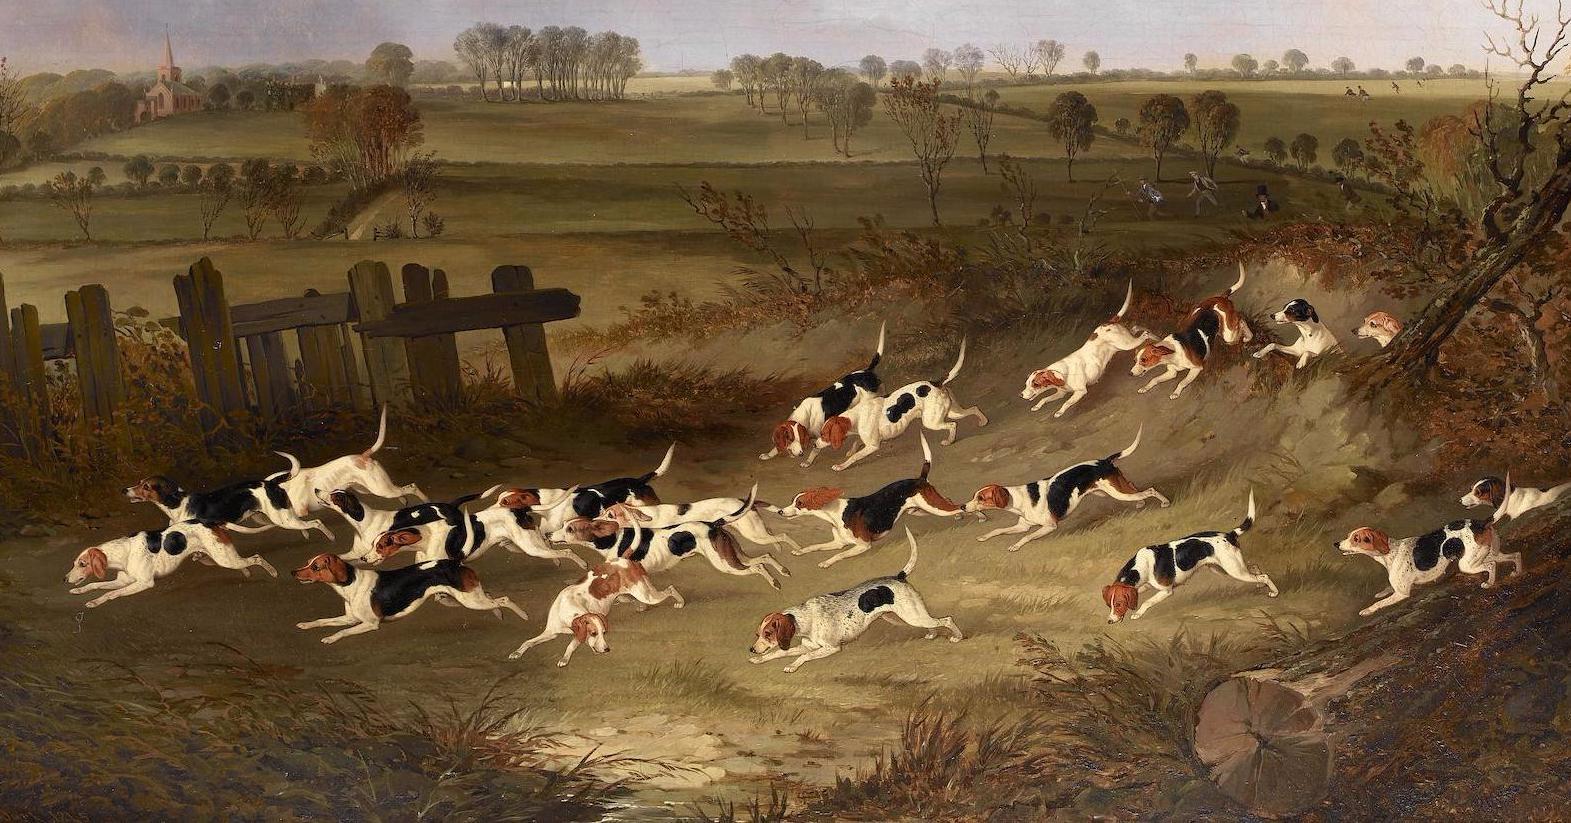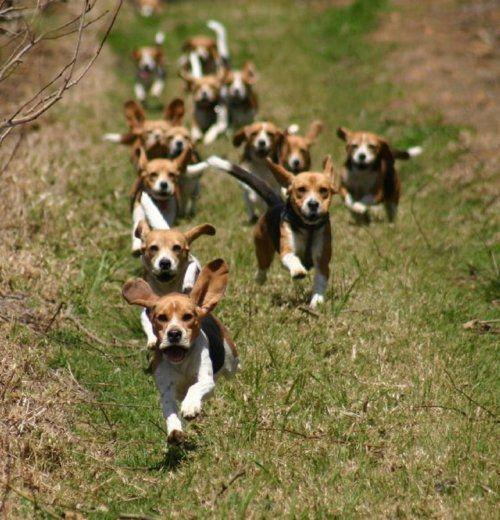The first image is the image on the left, the second image is the image on the right. Analyze the images presented: Is the assertion "Dogs are running in both pictures." valid? Answer yes or no. Yes. The first image is the image on the left, the second image is the image on the right. Evaluate the accuracy of this statement regarding the images: "Right image shows a pack of dogs running forward.". Is it true? Answer yes or no. Yes. 